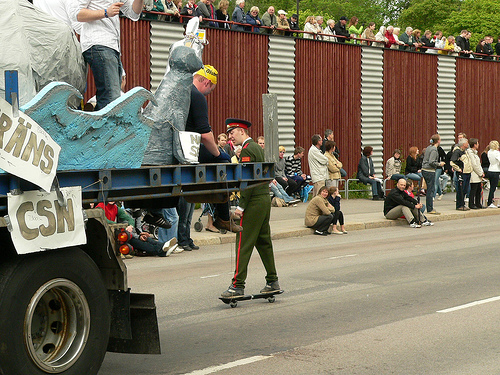<image>
Can you confirm if the tree is behind the man? Yes. From this viewpoint, the tree is positioned behind the man, with the man partially or fully occluding the tree. 